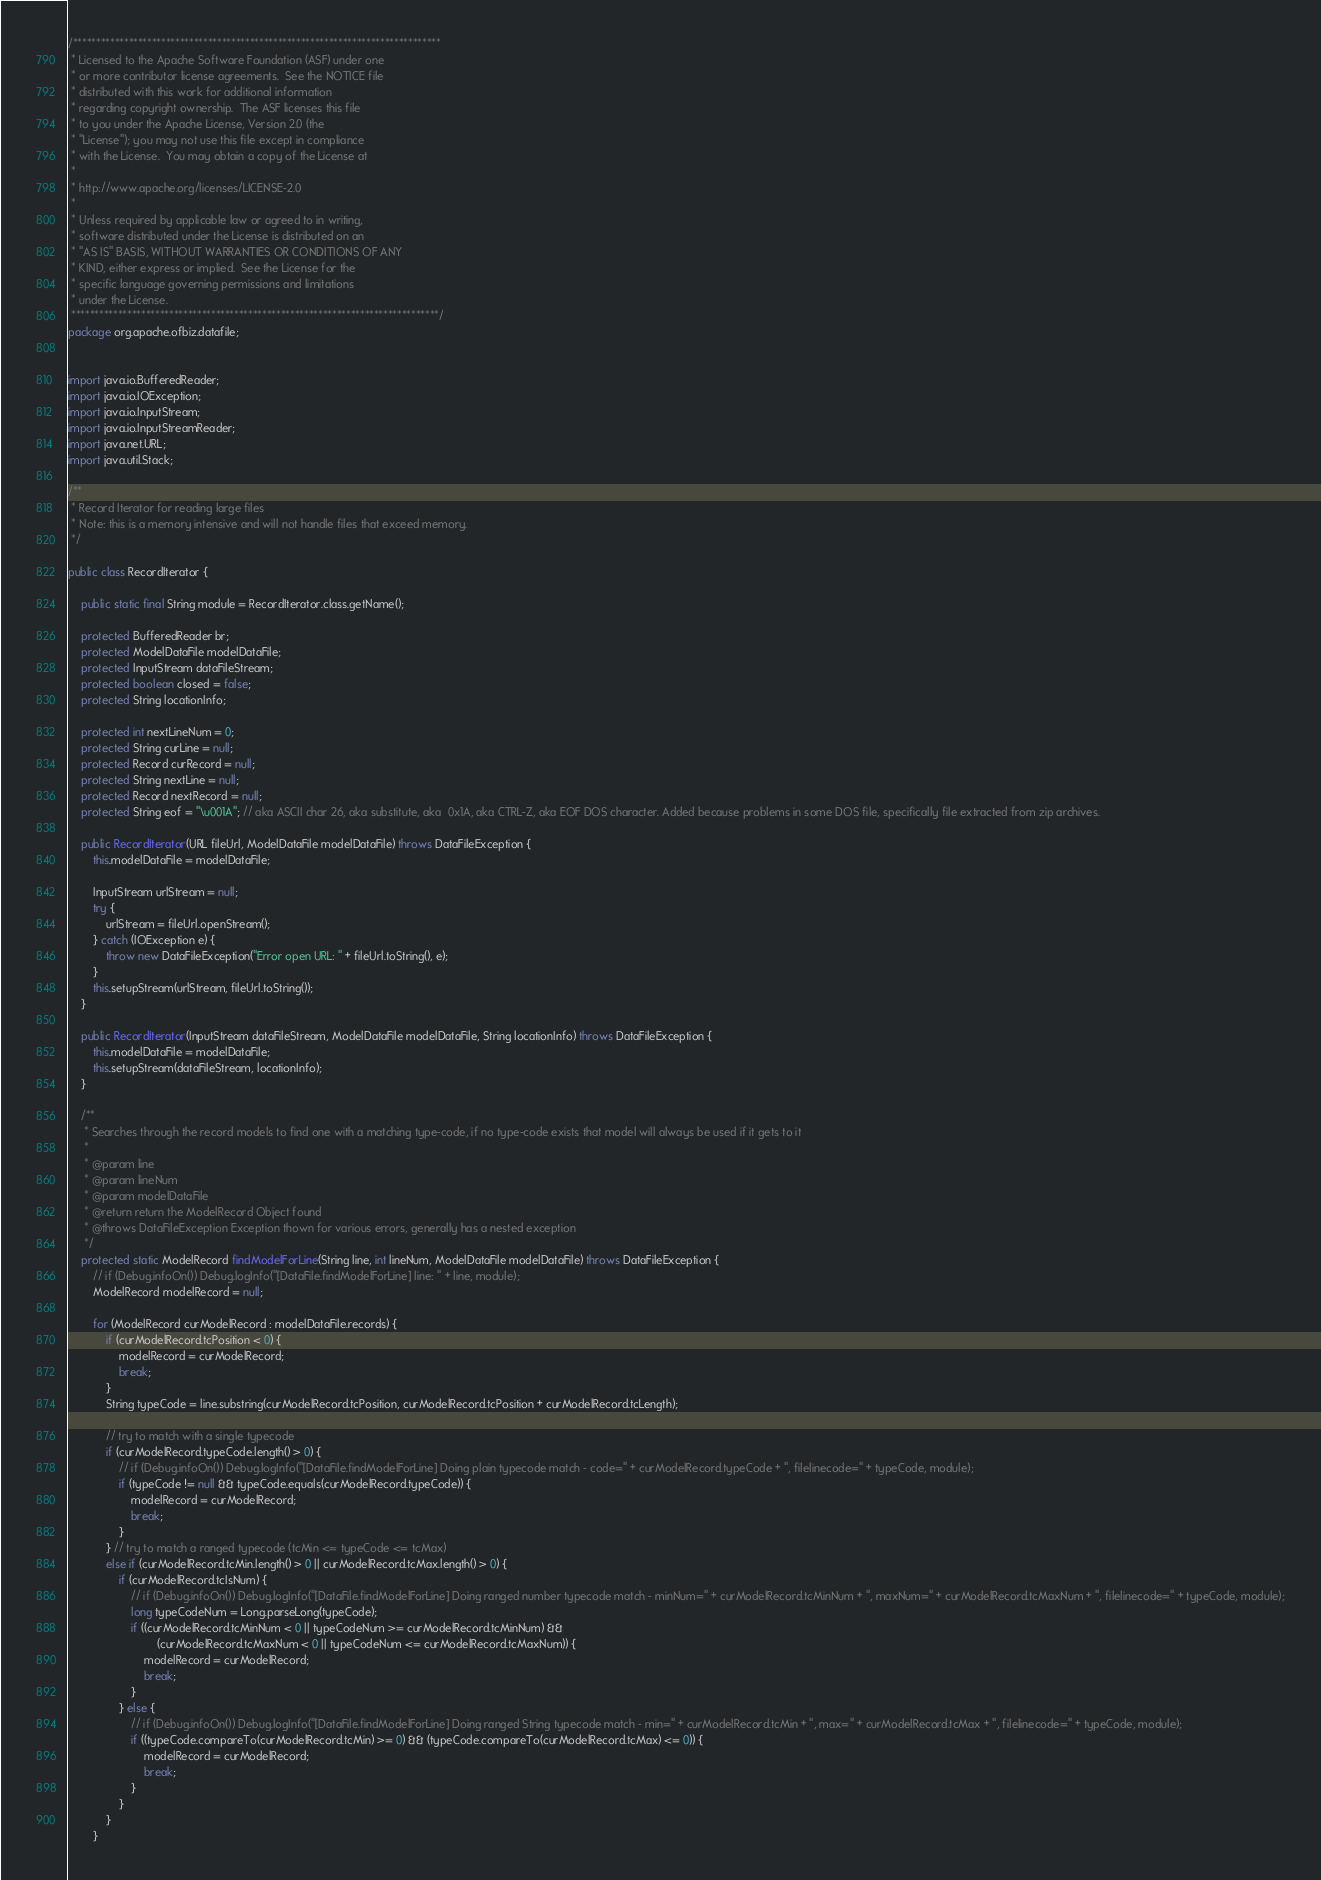<code> <loc_0><loc_0><loc_500><loc_500><_Java_>/*******************************************************************************
 * Licensed to the Apache Software Foundation (ASF) under one
 * or more contributor license agreements.  See the NOTICE file
 * distributed with this work for additional information
 * regarding copyright ownership.  The ASF licenses this file
 * to you under the Apache License, Version 2.0 (the
 * "License"); you may not use this file except in compliance
 * with the License.  You may obtain a copy of the License at
 *
 * http://www.apache.org/licenses/LICENSE-2.0
 *
 * Unless required by applicable law or agreed to in writing,
 * software distributed under the License is distributed on an
 * "AS IS" BASIS, WITHOUT WARRANTIES OR CONDITIONS OF ANY
 * KIND, either express or implied.  See the License for the
 * specific language governing permissions and limitations
 * under the License.
 *******************************************************************************/
package org.apache.ofbiz.datafile;


import java.io.BufferedReader;
import java.io.IOException;
import java.io.InputStream;
import java.io.InputStreamReader;
import java.net.URL;
import java.util.Stack;

/**
 * Record Iterator for reading large files
 * Note: this is a memory intensive and will not handle files that exceed memory.
 */

public class RecordIterator {

	public static final String module = RecordIterator.class.getName();

	protected BufferedReader br;
	protected ModelDataFile modelDataFile;
	protected InputStream dataFileStream;
	protected boolean closed = false;
	protected String locationInfo;

	protected int nextLineNum = 0;
	protected String curLine = null;
	protected Record curRecord = null;
	protected String nextLine = null;
	protected Record nextRecord = null;
	protected String eof = "\u001A"; // aka ASCII char 26, aka substitute, aka  0x1A, aka CTRL-Z, aka EOF DOS character. Added because problems in some DOS file, specifically file extracted from zip archives.

	public RecordIterator(URL fileUrl, ModelDataFile modelDataFile) throws DataFileException {
		this.modelDataFile = modelDataFile;

		InputStream urlStream = null;
		try {
			urlStream = fileUrl.openStream();
		} catch (IOException e) {
			throw new DataFileException("Error open URL: " + fileUrl.toString(), e);
		}
		this.setupStream(urlStream, fileUrl.toString());
	}

	public RecordIterator(InputStream dataFileStream, ModelDataFile modelDataFile, String locationInfo) throws DataFileException {
		this.modelDataFile = modelDataFile;
		this.setupStream(dataFileStream, locationInfo);
	}

	/**
	 * Searches through the record models to find one with a matching type-code, if no type-code exists that model will always be used if it gets to it
	 *
	 * @param line
	 * @param lineNum
	 * @param modelDataFile
	 * @return return the ModelRecord Object found
	 * @throws DataFileException Exception thown for various errors, generally has a nested exception
	 */
	protected static ModelRecord findModelForLine(String line, int lineNum, ModelDataFile modelDataFile) throws DataFileException {
		// if (Debug.infoOn()) Debug.logInfo("[DataFile.findModelForLine] line: " + line, module);
		ModelRecord modelRecord = null;

		for (ModelRecord curModelRecord : modelDataFile.records) {
			if (curModelRecord.tcPosition < 0) {
				modelRecord = curModelRecord;
				break;
			}
			String typeCode = line.substring(curModelRecord.tcPosition, curModelRecord.tcPosition + curModelRecord.tcLength);

			// try to match with a single typecode
			if (curModelRecord.typeCode.length() > 0) {
				// if (Debug.infoOn()) Debug.logInfo("[DataFile.findModelForLine] Doing plain typecode match - code=" + curModelRecord.typeCode + ", filelinecode=" + typeCode, module);
				if (typeCode != null && typeCode.equals(curModelRecord.typeCode)) {
					modelRecord = curModelRecord;
					break;
				}
			} // try to match a ranged typecode (tcMin <= typeCode <= tcMax)
			else if (curModelRecord.tcMin.length() > 0 || curModelRecord.tcMax.length() > 0) {
				if (curModelRecord.tcIsNum) {
					// if (Debug.infoOn()) Debug.logInfo("[DataFile.findModelForLine] Doing ranged number typecode match - minNum=" + curModelRecord.tcMinNum + ", maxNum=" + curModelRecord.tcMaxNum + ", filelinecode=" + typeCode, module);
					long typeCodeNum = Long.parseLong(typeCode);
					if ((curModelRecord.tcMinNum < 0 || typeCodeNum >= curModelRecord.tcMinNum) &&
							(curModelRecord.tcMaxNum < 0 || typeCodeNum <= curModelRecord.tcMaxNum)) {
						modelRecord = curModelRecord;
						break;
					}
				} else {
					// if (Debug.infoOn()) Debug.logInfo("[DataFile.findModelForLine] Doing ranged String typecode match - min=" + curModelRecord.tcMin + ", max=" + curModelRecord.tcMax + ", filelinecode=" + typeCode, module);
					if ((typeCode.compareTo(curModelRecord.tcMin) >= 0) && (typeCode.compareTo(curModelRecord.tcMax) <= 0)) {
						modelRecord = curModelRecord;
						break;
					}
				}
			}
		}
</code> 